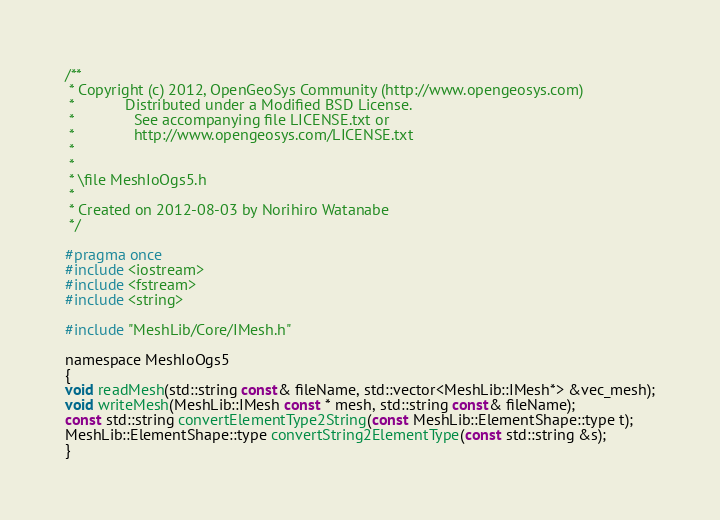<code> <loc_0><loc_0><loc_500><loc_500><_C_>/**
 * Copyright (c) 2012, OpenGeoSys Community (http://www.opengeosys.com)
 *            Distributed under a Modified BSD License.
 *              See accompanying file LICENSE.txt or
 *              http://www.opengeosys.com/LICENSE.txt
 *
 *
 * \file MeshIoOgs5.h
 *
 * Created on 2012-08-03 by Norihiro Watanabe
 */

#pragma once
#include <iostream>
#include <fstream>
#include <string>

#include "MeshLib/Core/IMesh.h"

namespace MeshIoOgs5
{
void readMesh(std::string const& fileName, std::vector<MeshLib::IMesh*> &vec_mesh);
void writeMesh(MeshLib::IMesh const * mesh, std::string const& fileName);
const std::string convertElementType2String(const MeshLib::ElementShape::type t);
MeshLib::ElementShape::type convertString2ElementType(const std::string &s);
}

</code> 